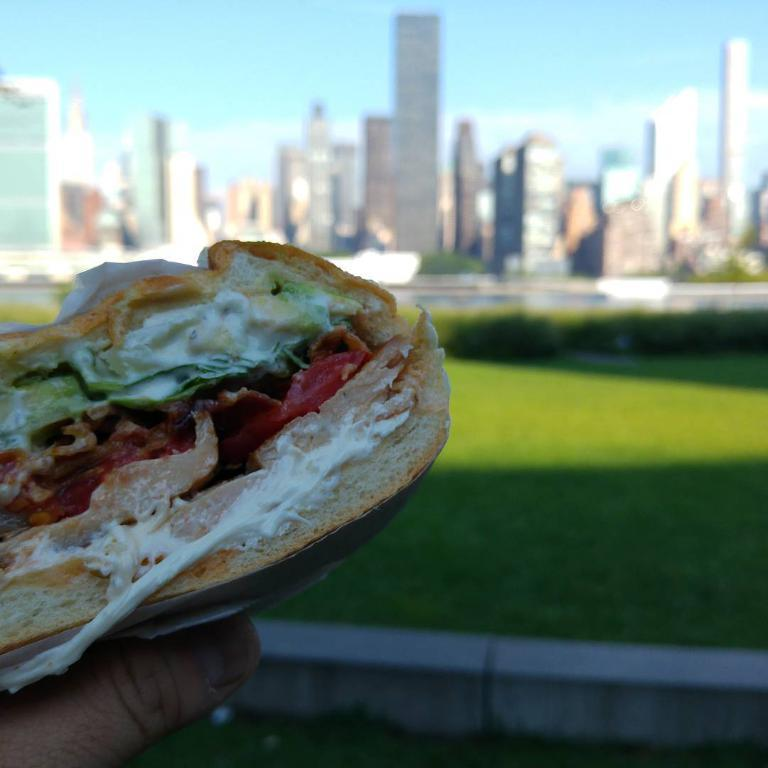What is the human hand holding in the image? There is a human hand holding a food item in the image. What can be seen in the background of the image? The background of the image includes the sky, buildings, grass, and plants. Can you describe the natural elements visible in the background? Grass and plants are visible in the background. Where is the sister standing with the hammer in the image? There is no sister or hammer present in the image. What type of goat can be seen grazing in the background of the image? There is no goat present in the image; the background features the sky, buildings, grass, and plants. 